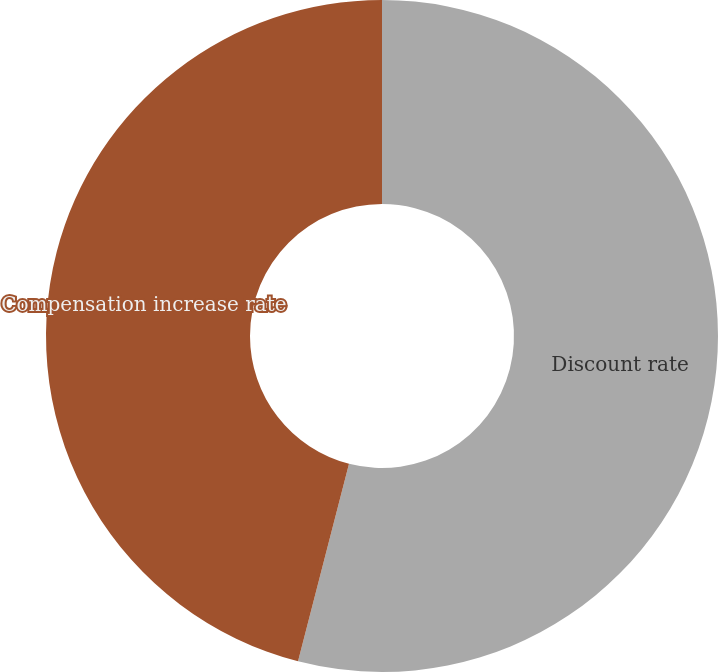Convert chart. <chart><loc_0><loc_0><loc_500><loc_500><pie_chart><fcel>Discount rate<fcel>Compensation increase rate<nl><fcel>54.02%<fcel>45.98%<nl></chart> 